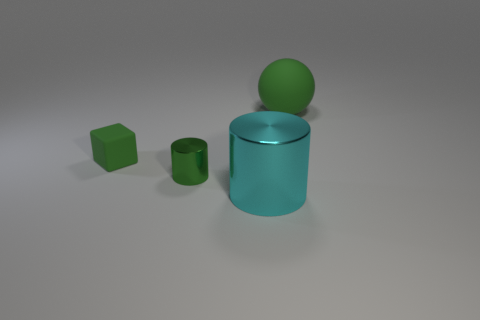Are there the same number of green spheres to the left of the matte cube and large things that are to the left of the large cyan thing?
Ensure brevity in your answer.  Yes. What color is the object that is both to the right of the small green cylinder and behind the big cyan cylinder?
Your response must be concise. Green. Is there any other thing that has the same size as the matte block?
Ensure brevity in your answer.  Yes. Is the number of cyan cylinders to the left of the green matte cube greater than the number of big spheres that are to the right of the sphere?
Your answer should be compact. No. Is the size of the rubber object that is in front of the green ball the same as the tiny green cylinder?
Offer a very short reply. Yes. There is a small green rubber cube in front of the big object that is on the right side of the large cyan thing; how many cubes are in front of it?
Make the answer very short. 0. There is a green thing that is both on the right side of the small rubber cube and left of the cyan cylinder; what size is it?
Offer a terse response. Small. How many other objects are the same shape as the tiny matte object?
Keep it short and to the point. 0. How many matte objects are behind the tiny green cube?
Make the answer very short. 1. Are there fewer tiny matte cubes behind the big cyan cylinder than tiny green blocks that are on the right side of the matte block?
Make the answer very short. No. 